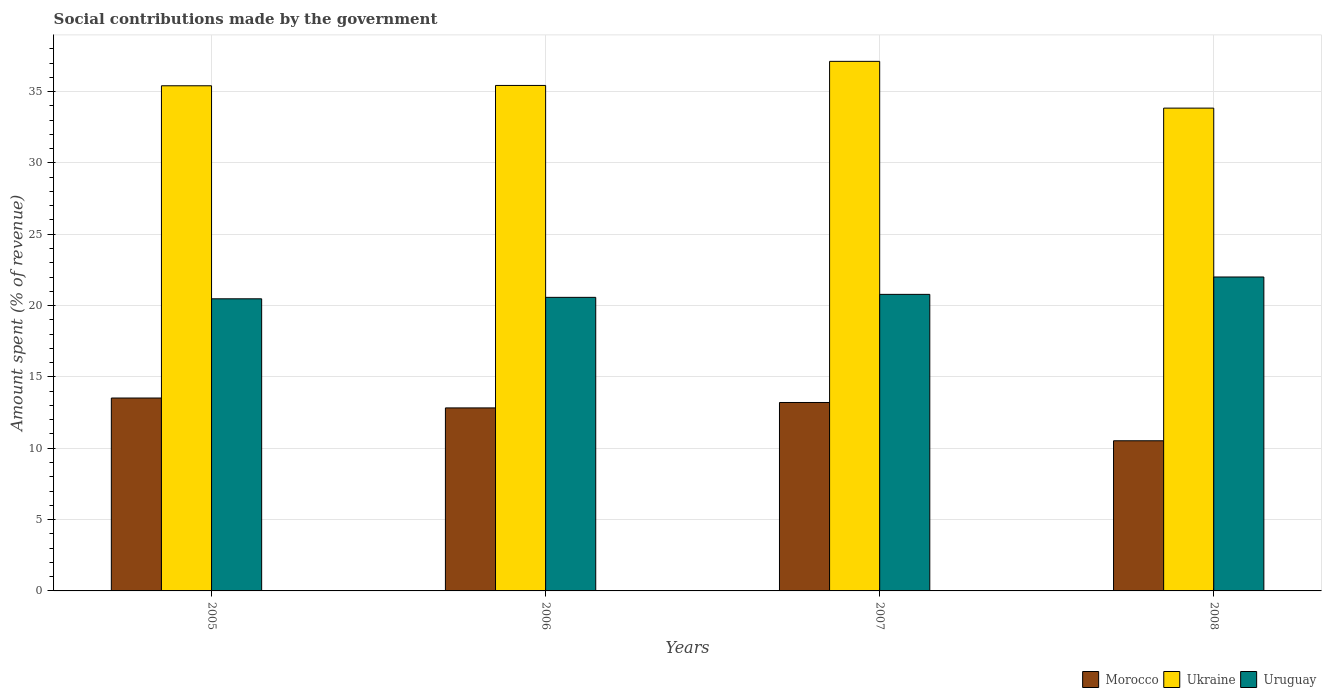How many bars are there on the 2nd tick from the left?
Your response must be concise. 3. How many bars are there on the 4th tick from the right?
Your answer should be very brief. 3. In how many cases, is the number of bars for a given year not equal to the number of legend labels?
Keep it short and to the point. 0. What is the amount spent (in %) on social contributions in Morocco in 2007?
Your answer should be very brief. 13.21. Across all years, what is the maximum amount spent (in %) on social contributions in Ukraine?
Offer a very short reply. 37.12. Across all years, what is the minimum amount spent (in %) on social contributions in Morocco?
Provide a short and direct response. 10.52. In which year was the amount spent (in %) on social contributions in Uruguay maximum?
Give a very brief answer. 2008. In which year was the amount spent (in %) on social contributions in Morocco minimum?
Your answer should be compact. 2008. What is the total amount spent (in %) on social contributions in Uruguay in the graph?
Your answer should be very brief. 83.84. What is the difference between the amount spent (in %) on social contributions in Morocco in 2005 and that in 2008?
Your response must be concise. 3. What is the difference between the amount spent (in %) on social contributions in Ukraine in 2007 and the amount spent (in %) on social contributions in Morocco in 2008?
Make the answer very short. 26.59. What is the average amount spent (in %) on social contributions in Morocco per year?
Your answer should be very brief. 12.52. In the year 2007, what is the difference between the amount spent (in %) on social contributions in Ukraine and amount spent (in %) on social contributions in Morocco?
Your answer should be compact. 23.91. What is the ratio of the amount spent (in %) on social contributions in Morocco in 2005 to that in 2008?
Your answer should be compact. 1.28. What is the difference between the highest and the second highest amount spent (in %) on social contributions in Ukraine?
Provide a short and direct response. 1.69. What is the difference between the highest and the lowest amount spent (in %) on social contributions in Uruguay?
Provide a short and direct response. 1.53. Is the sum of the amount spent (in %) on social contributions in Uruguay in 2005 and 2007 greater than the maximum amount spent (in %) on social contributions in Ukraine across all years?
Provide a succinct answer. Yes. What does the 2nd bar from the left in 2008 represents?
Provide a short and direct response. Ukraine. What does the 2nd bar from the right in 2008 represents?
Provide a succinct answer. Ukraine. How many bars are there?
Ensure brevity in your answer.  12. Does the graph contain grids?
Ensure brevity in your answer.  Yes. How are the legend labels stacked?
Provide a succinct answer. Horizontal. What is the title of the graph?
Offer a terse response. Social contributions made by the government. What is the label or title of the X-axis?
Offer a very short reply. Years. What is the label or title of the Y-axis?
Your response must be concise. Amount spent (% of revenue). What is the Amount spent (% of revenue) in Morocco in 2005?
Offer a terse response. 13.52. What is the Amount spent (% of revenue) of Ukraine in 2005?
Provide a short and direct response. 35.4. What is the Amount spent (% of revenue) in Uruguay in 2005?
Your answer should be compact. 20.47. What is the Amount spent (% of revenue) in Morocco in 2006?
Your answer should be compact. 12.83. What is the Amount spent (% of revenue) in Ukraine in 2006?
Ensure brevity in your answer.  35.43. What is the Amount spent (% of revenue) of Uruguay in 2006?
Make the answer very short. 20.58. What is the Amount spent (% of revenue) of Morocco in 2007?
Give a very brief answer. 13.21. What is the Amount spent (% of revenue) of Ukraine in 2007?
Keep it short and to the point. 37.12. What is the Amount spent (% of revenue) of Uruguay in 2007?
Make the answer very short. 20.79. What is the Amount spent (% of revenue) in Morocco in 2008?
Offer a terse response. 10.52. What is the Amount spent (% of revenue) of Ukraine in 2008?
Your response must be concise. 33.84. What is the Amount spent (% of revenue) in Uruguay in 2008?
Keep it short and to the point. 22. Across all years, what is the maximum Amount spent (% of revenue) in Morocco?
Keep it short and to the point. 13.52. Across all years, what is the maximum Amount spent (% of revenue) of Ukraine?
Your response must be concise. 37.12. Across all years, what is the maximum Amount spent (% of revenue) in Uruguay?
Provide a short and direct response. 22. Across all years, what is the minimum Amount spent (% of revenue) in Morocco?
Offer a very short reply. 10.52. Across all years, what is the minimum Amount spent (% of revenue) of Ukraine?
Give a very brief answer. 33.84. Across all years, what is the minimum Amount spent (% of revenue) in Uruguay?
Keep it short and to the point. 20.47. What is the total Amount spent (% of revenue) in Morocco in the graph?
Your response must be concise. 50.08. What is the total Amount spent (% of revenue) of Ukraine in the graph?
Your answer should be very brief. 141.79. What is the total Amount spent (% of revenue) of Uruguay in the graph?
Your answer should be compact. 83.84. What is the difference between the Amount spent (% of revenue) in Morocco in 2005 and that in 2006?
Your response must be concise. 0.69. What is the difference between the Amount spent (% of revenue) of Ukraine in 2005 and that in 2006?
Your response must be concise. -0.02. What is the difference between the Amount spent (% of revenue) of Uruguay in 2005 and that in 2006?
Offer a terse response. -0.1. What is the difference between the Amount spent (% of revenue) in Morocco in 2005 and that in 2007?
Your answer should be compact. 0.31. What is the difference between the Amount spent (% of revenue) in Ukraine in 2005 and that in 2007?
Offer a terse response. -1.71. What is the difference between the Amount spent (% of revenue) in Uruguay in 2005 and that in 2007?
Keep it short and to the point. -0.31. What is the difference between the Amount spent (% of revenue) of Morocco in 2005 and that in 2008?
Ensure brevity in your answer.  3. What is the difference between the Amount spent (% of revenue) of Ukraine in 2005 and that in 2008?
Your response must be concise. 1.57. What is the difference between the Amount spent (% of revenue) in Uruguay in 2005 and that in 2008?
Ensure brevity in your answer.  -1.53. What is the difference between the Amount spent (% of revenue) in Morocco in 2006 and that in 2007?
Offer a very short reply. -0.38. What is the difference between the Amount spent (% of revenue) in Ukraine in 2006 and that in 2007?
Give a very brief answer. -1.69. What is the difference between the Amount spent (% of revenue) of Uruguay in 2006 and that in 2007?
Provide a succinct answer. -0.21. What is the difference between the Amount spent (% of revenue) of Morocco in 2006 and that in 2008?
Your answer should be very brief. 2.3. What is the difference between the Amount spent (% of revenue) in Ukraine in 2006 and that in 2008?
Offer a very short reply. 1.59. What is the difference between the Amount spent (% of revenue) in Uruguay in 2006 and that in 2008?
Ensure brevity in your answer.  -1.43. What is the difference between the Amount spent (% of revenue) in Morocco in 2007 and that in 2008?
Offer a very short reply. 2.68. What is the difference between the Amount spent (% of revenue) in Ukraine in 2007 and that in 2008?
Provide a short and direct response. 3.28. What is the difference between the Amount spent (% of revenue) of Uruguay in 2007 and that in 2008?
Your answer should be compact. -1.22. What is the difference between the Amount spent (% of revenue) in Morocco in 2005 and the Amount spent (% of revenue) in Ukraine in 2006?
Your answer should be very brief. -21.91. What is the difference between the Amount spent (% of revenue) of Morocco in 2005 and the Amount spent (% of revenue) of Uruguay in 2006?
Keep it short and to the point. -7.06. What is the difference between the Amount spent (% of revenue) in Ukraine in 2005 and the Amount spent (% of revenue) in Uruguay in 2006?
Keep it short and to the point. 14.83. What is the difference between the Amount spent (% of revenue) of Morocco in 2005 and the Amount spent (% of revenue) of Ukraine in 2007?
Keep it short and to the point. -23.6. What is the difference between the Amount spent (% of revenue) of Morocco in 2005 and the Amount spent (% of revenue) of Uruguay in 2007?
Make the answer very short. -7.26. What is the difference between the Amount spent (% of revenue) in Ukraine in 2005 and the Amount spent (% of revenue) in Uruguay in 2007?
Keep it short and to the point. 14.62. What is the difference between the Amount spent (% of revenue) of Morocco in 2005 and the Amount spent (% of revenue) of Ukraine in 2008?
Make the answer very short. -20.32. What is the difference between the Amount spent (% of revenue) of Morocco in 2005 and the Amount spent (% of revenue) of Uruguay in 2008?
Ensure brevity in your answer.  -8.48. What is the difference between the Amount spent (% of revenue) in Ukraine in 2005 and the Amount spent (% of revenue) in Uruguay in 2008?
Give a very brief answer. 13.4. What is the difference between the Amount spent (% of revenue) of Morocco in 2006 and the Amount spent (% of revenue) of Ukraine in 2007?
Offer a terse response. -24.29. What is the difference between the Amount spent (% of revenue) in Morocco in 2006 and the Amount spent (% of revenue) in Uruguay in 2007?
Offer a terse response. -7.96. What is the difference between the Amount spent (% of revenue) in Ukraine in 2006 and the Amount spent (% of revenue) in Uruguay in 2007?
Offer a very short reply. 14.64. What is the difference between the Amount spent (% of revenue) of Morocco in 2006 and the Amount spent (% of revenue) of Ukraine in 2008?
Your answer should be very brief. -21.01. What is the difference between the Amount spent (% of revenue) of Morocco in 2006 and the Amount spent (% of revenue) of Uruguay in 2008?
Offer a very short reply. -9.18. What is the difference between the Amount spent (% of revenue) in Ukraine in 2006 and the Amount spent (% of revenue) in Uruguay in 2008?
Offer a terse response. 13.43. What is the difference between the Amount spent (% of revenue) in Morocco in 2007 and the Amount spent (% of revenue) in Ukraine in 2008?
Your answer should be very brief. -20.63. What is the difference between the Amount spent (% of revenue) in Morocco in 2007 and the Amount spent (% of revenue) in Uruguay in 2008?
Give a very brief answer. -8.8. What is the difference between the Amount spent (% of revenue) of Ukraine in 2007 and the Amount spent (% of revenue) of Uruguay in 2008?
Offer a very short reply. 15.11. What is the average Amount spent (% of revenue) of Morocco per year?
Offer a very short reply. 12.52. What is the average Amount spent (% of revenue) in Ukraine per year?
Ensure brevity in your answer.  35.45. What is the average Amount spent (% of revenue) in Uruguay per year?
Your answer should be compact. 20.96. In the year 2005, what is the difference between the Amount spent (% of revenue) of Morocco and Amount spent (% of revenue) of Ukraine?
Give a very brief answer. -21.88. In the year 2005, what is the difference between the Amount spent (% of revenue) of Morocco and Amount spent (% of revenue) of Uruguay?
Make the answer very short. -6.95. In the year 2005, what is the difference between the Amount spent (% of revenue) of Ukraine and Amount spent (% of revenue) of Uruguay?
Offer a terse response. 14.93. In the year 2006, what is the difference between the Amount spent (% of revenue) of Morocco and Amount spent (% of revenue) of Ukraine?
Make the answer very short. -22.6. In the year 2006, what is the difference between the Amount spent (% of revenue) in Morocco and Amount spent (% of revenue) in Uruguay?
Provide a succinct answer. -7.75. In the year 2006, what is the difference between the Amount spent (% of revenue) of Ukraine and Amount spent (% of revenue) of Uruguay?
Your response must be concise. 14.85. In the year 2007, what is the difference between the Amount spent (% of revenue) in Morocco and Amount spent (% of revenue) in Ukraine?
Provide a short and direct response. -23.91. In the year 2007, what is the difference between the Amount spent (% of revenue) in Morocco and Amount spent (% of revenue) in Uruguay?
Keep it short and to the point. -7.58. In the year 2007, what is the difference between the Amount spent (% of revenue) in Ukraine and Amount spent (% of revenue) in Uruguay?
Make the answer very short. 16.33. In the year 2008, what is the difference between the Amount spent (% of revenue) of Morocco and Amount spent (% of revenue) of Ukraine?
Provide a succinct answer. -23.32. In the year 2008, what is the difference between the Amount spent (% of revenue) of Morocco and Amount spent (% of revenue) of Uruguay?
Give a very brief answer. -11.48. In the year 2008, what is the difference between the Amount spent (% of revenue) in Ukraine and Amount spent (% of revenue) in Uruguay?
Give a very brief answer. 11.84. What is the ratio of the Amount spent (% of revenue) in Morocco in 2005 to that in 2006?
Your response must be concise. 1.05. What is the ratio of the Amount spent (% of revenue) of Uruguay in 2005 to that in 2006?
Provide a short and direct response. 0.99. What is the ratio of the Amount spent (% of revenue) in Morocco in 2005 to that in 2007?
Offer a terse response. 1.02. What is the ratio of the Amount spent (% of revenue) in Ukraine in 2005 to that in 2007?
Provide a short and direct response. 0.95. What is the ratio of the Amount spent (% of revenue) of Uruguay in 2005 to that in 2007?
Make the answer very short. 0.98. What is the ratio of the Amount spent (% of revenue) in Morocco in 2005 to that in 2008?
Give a very brief answer. 1.28. What is the ratio of the Amount spent (% of revenue) in Ukraine in 2005 to that in 2008?
Give a very brief answer. 1.05. What is the ratio of the Amount spent (% of revenue) in Uruguay in 2005 to that in 2008?
Give a very brief answer. 0.93. What is the ratio of the Amount spent (% of revenue) of Morocco in 2006 to that in 2007?
Offer a very short reply. 0.97. What is the ratio of the Amount spent (% of revenue) of Ukraine in 2006 to that in 2007?
Your answer should be very brief. 0.95. What is the ratio of the Amount spent (% of revenue) in Uruguay in 2006 to that in 2007?
Your response must be concise. 0.99. What is the ratio of the Amount spent (% of revenue) of Morocco in 2006 to that in 2008?
Your answer should be compact. 1.22. What is the ratio of the Amount spent (% of revenue) in Ukraine in 2006 to that in 2008?
Offer a terse response. 1.05. What is the ratio of the Amount spent (% of revenue) of Uruguay in 2006 to that in 2008?
Your answer should be very brief. 0.94. What is the ratio of the Amount spent (% of revenue) in Morocco in 2007 to that in 2008?
Ensure brevity in your answer.  1.25. What is the ratio of the Amount spent (% of revenue) of Ukraine in 2007 to that in 2008?
Make the answer very short. 1.1. What is the ratio of the Amount spent (% of revenue) in Uruguay in 2007 to that in 2008?
Offer a terse response. 0.94. What is the difference between the highest and the second highest Amount spent (% of revenue) of Morocco?
Provide a short and direct response. 0.31. What is the difference between the highest and the second highest Amount spent (% of revenue) of Ukraine?
Provide a succinct answer. 1.69. What is the difference between the highest and the second highest Amount spent (% of revenue) in Uruguay?
Provide a succinct answer. 1.22. What is the difference between the highest and the lowest Amount spent (% of revenue) in Morocco?
Offer a terse response. 3. What is the difference between the highest and the lowest Amount spent (% of revenue) of Ukraine?
Your answer should be compact. 3.28. What is the difference between the highest and the lowest Amount spent (% of revenue) of Uruguay?
Offer a very short reply. 1.53. 